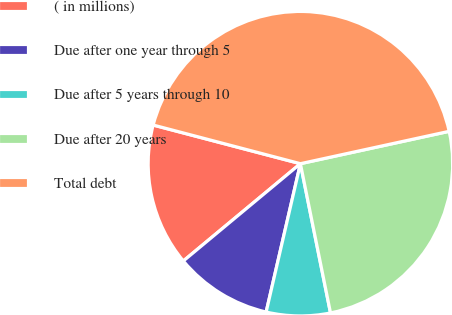Convert chart to OTSL. <chart><loc_0><loc_0><loc_500><loc_500><pie_chart><fcel>( in millions)<fcel>Due after one year through 5<fcel>Due after 5 years through 10<fcel>Due after 20 years<fcel>Total debt<nl><fcel>15.12%<fcel>10.35%<fcel>6.78%<fcel>25.24%<fcel>42.5%<nl></chart> 